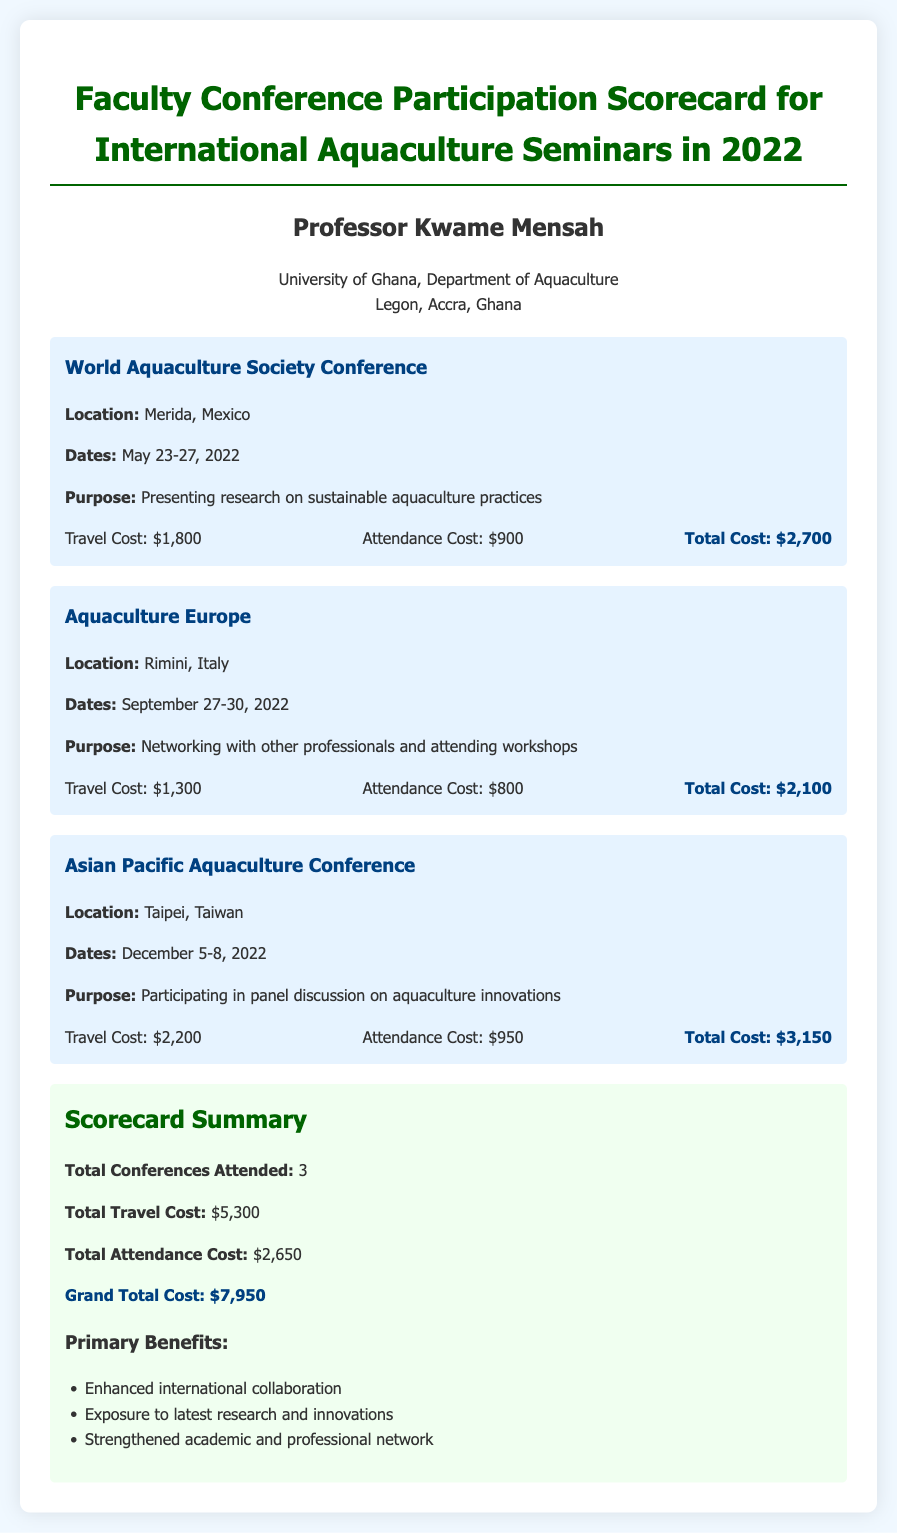What is the name of the professor? The document mentions the name of the professor as "Professor Kwame Mensah."
Answer: Professor Kwame Mensah How many conferences did Professor Mensah attend? The scorecard summary states the total number of conferences attended is 3.
Answer: 3 What was the travel cost for the World Aquaculture Society Conference? The document provides the travel cost for this conference as $1,800.
Answer: $1,800 Which conference took place in Rimini, Italy? The document identifies the conference in Rimini, Italy as "Aquaculture Europe."
Answer: Aquaculture Europe What is the total attendance cost listed in the summary? The summary section indicates that the total attendance cost is $2,650.
Answer: $2,650 What was the purpose of attending the Asian Pacific Aquaculture Conference? The document mentions the purpose as participating in a panel discussion on aquaculture innovations.
Answer: Participating in panel discussion on aquaculture innovations What is the grand total cost for all conferences? The final figure in the summary states that the grand total cost is $7,950.
Answer: $7,950 What is one of the primary benefits mentioned in the scorecard? The scorecard lists several primary benefits; one of them is "Enhanced international collaboration."
Answer: Enhanced international collaboration 